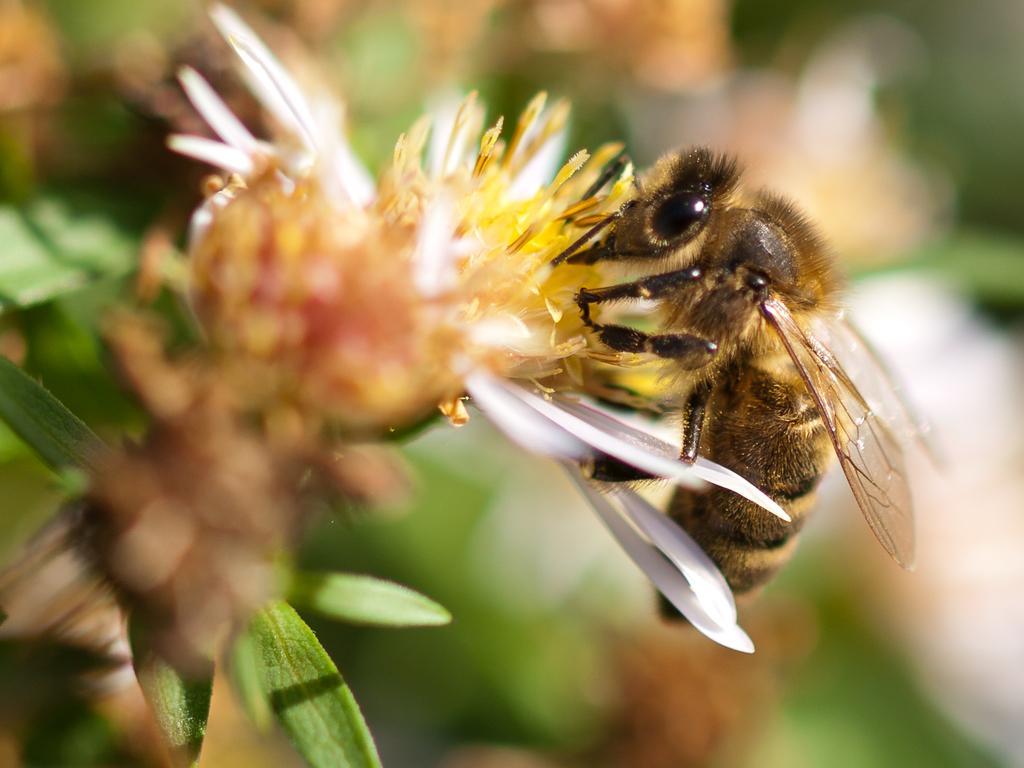Can you describe this image briefly? In this image I can see an insect which is in black and brown color. It is on the flower. And I can see the blurred background. 